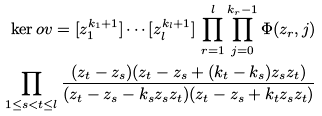Convert formula to latex. <formula><loc_0><loc_0><loc_500><loc_500>\ker o v = [ z _ { 1 } ^ { k _ { 1 } + 1 } ] \cdots [ z _ { l } ^ { k _ { l } + 1 } ] \, \prod _ { r = 1 } ^ { l } \prod _ { j = 0 } ^ { k _ { r } - 1 } \Phi ( z _ { r } , j ) \\ \prod _ { 1 \leq s < t \leq l } \frac { ( z _ { t } - z _ { s } ) ( z _ { t } - z _ { s } + ( k _ { t } - k _ { s } ) z _ { s } z _ { t } ) } { ( z _ { t } - z _ { s } - k _ { s } z _ { s } z _ { t } ) ( z _ { t } - z _ { s } + k _ { t } z _ { s } z _ { t } ) }</formula> 